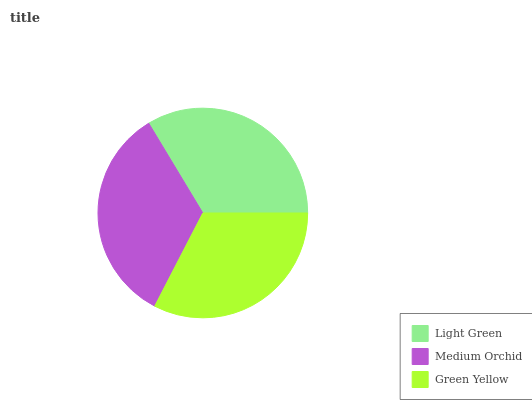Is Green Yellow the minimum?
Answer yes or no. Yes. Is Medium Orchid the maximum?
Answer yes or no. Yes. Is Medium Orchid the minimum?
Answer yes or no. No. Is Green Yellow the maximum?
Answer yes or no. No. Is Medium Orchid greater than Green Yellow?
Answer yes or no. Yes. Is Green Yellow less than Medium Orchid?
Answer yes or no. Yes. Is Green Yellow greater than Medium Orchid?
Answer yes or no. No. Is Medium Orchid less than Green Yellow?
Answer yes or no. No. Is Light Green the high median?
Answer yes or no. Yes. Is Light Green the low median?
Answer yes or no. Yes. Is Medium Orchid the high median?
Answer yes or no. No. Is Green Yellow the low median?
Answer yes or no. No. 